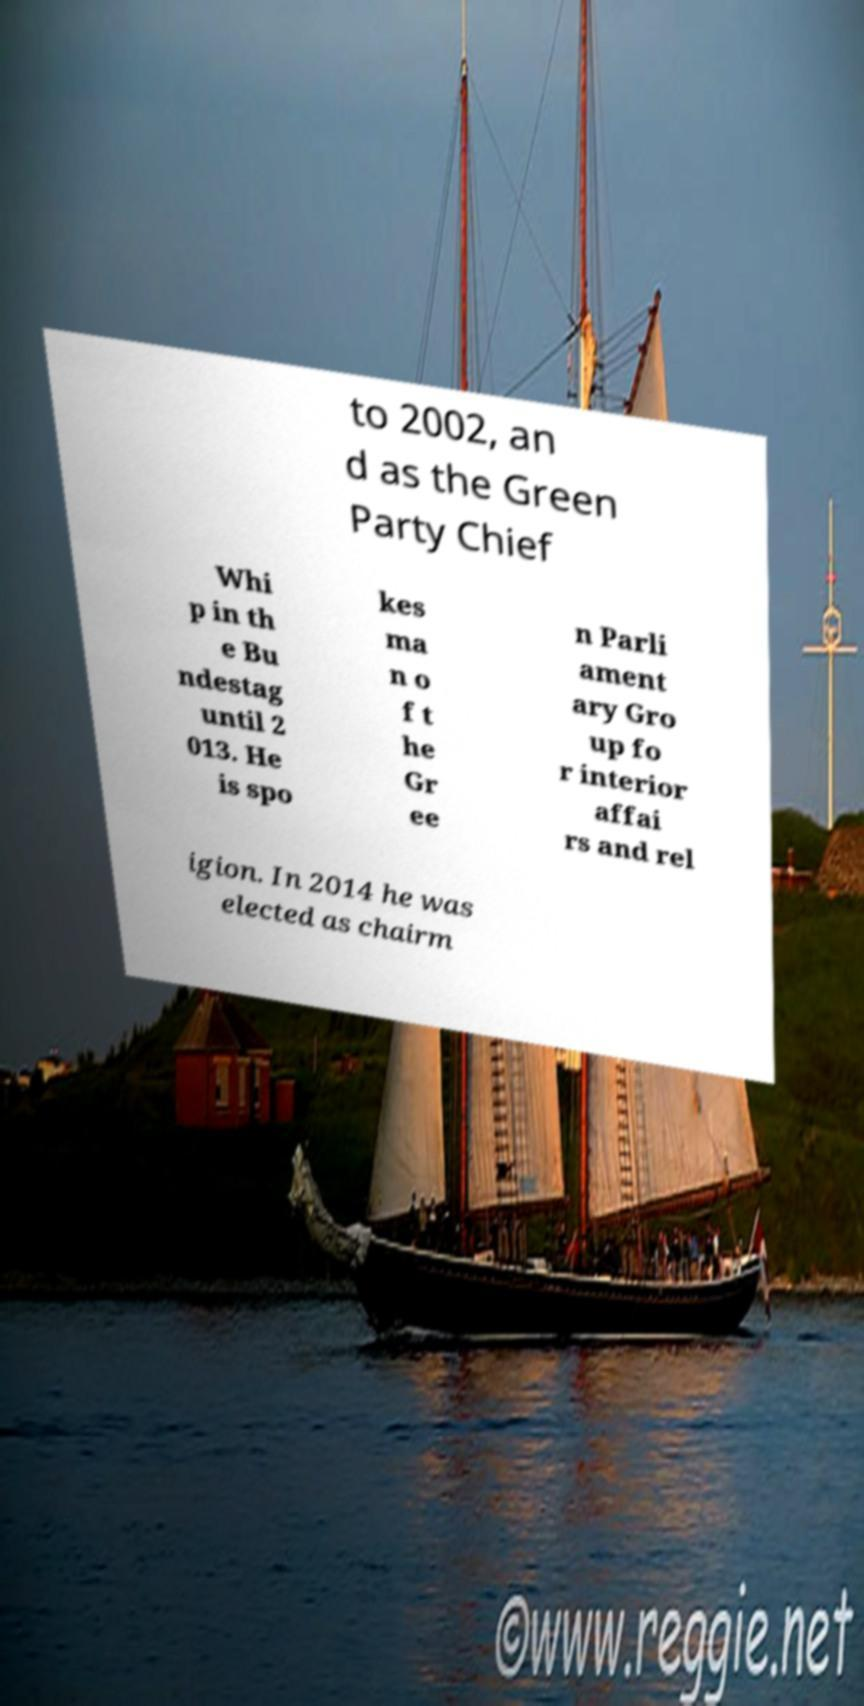I need the written content from this picture converted into text. Can you do that? to 2002, an d as the Green Party Chief Whi p in th e Bu ndestag until 2 013. He is spo kes ma n o f t he Gr ee n Parli ament ary Gro up fo r interior affai rs and rel igion. In 2014 he was elected as chairm 